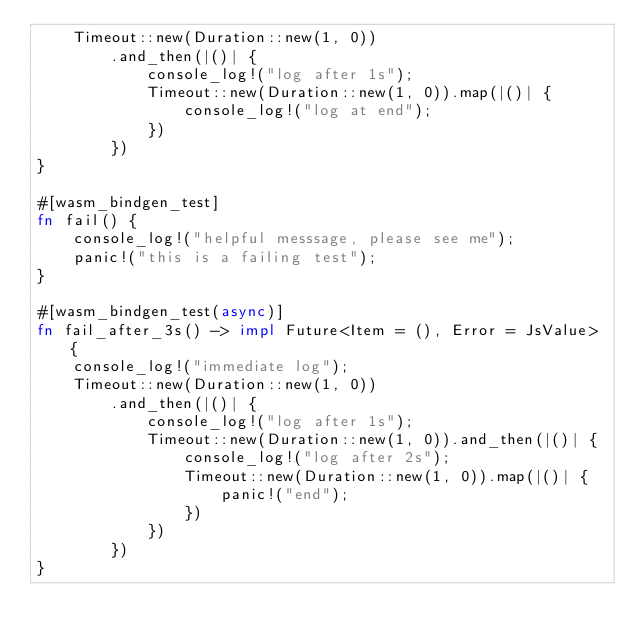Convert code to text. <code><loc_0><loc_0><loc_500><loc_500><_Rust_>    Timeout::new(Duration::new(1, 0))
        .and_then(|()| {
            console_log!("log after 1s");
            Timeout::new(Duration::new(1, 0)).map(|()| {
                console_log!("log at end");
            })
        })
}

#[wasm_bindgen_test]
fn fail() {
    console_log!("helpful messsage, please see me");
    panic!("this is a failing test");
}

#[wasm_bindgen_test(async)]
fn fail_after_3s() -> impl Future<Item = (), Error = JsValue> {
    console_log!("immediate log");
    Timeout::new(Duration::new(1, 0))
        .and_then(|()| {
            console_log!("log after 1s");
            Timeout::new(Duration::new(1, 0)).and_then(|()| {
                console_log!("log after 2s");
                Timeout::new(Duration::new(1, 0)).map(|()| {
                    panic!("end");
                })
            })
        })
}

</code> 